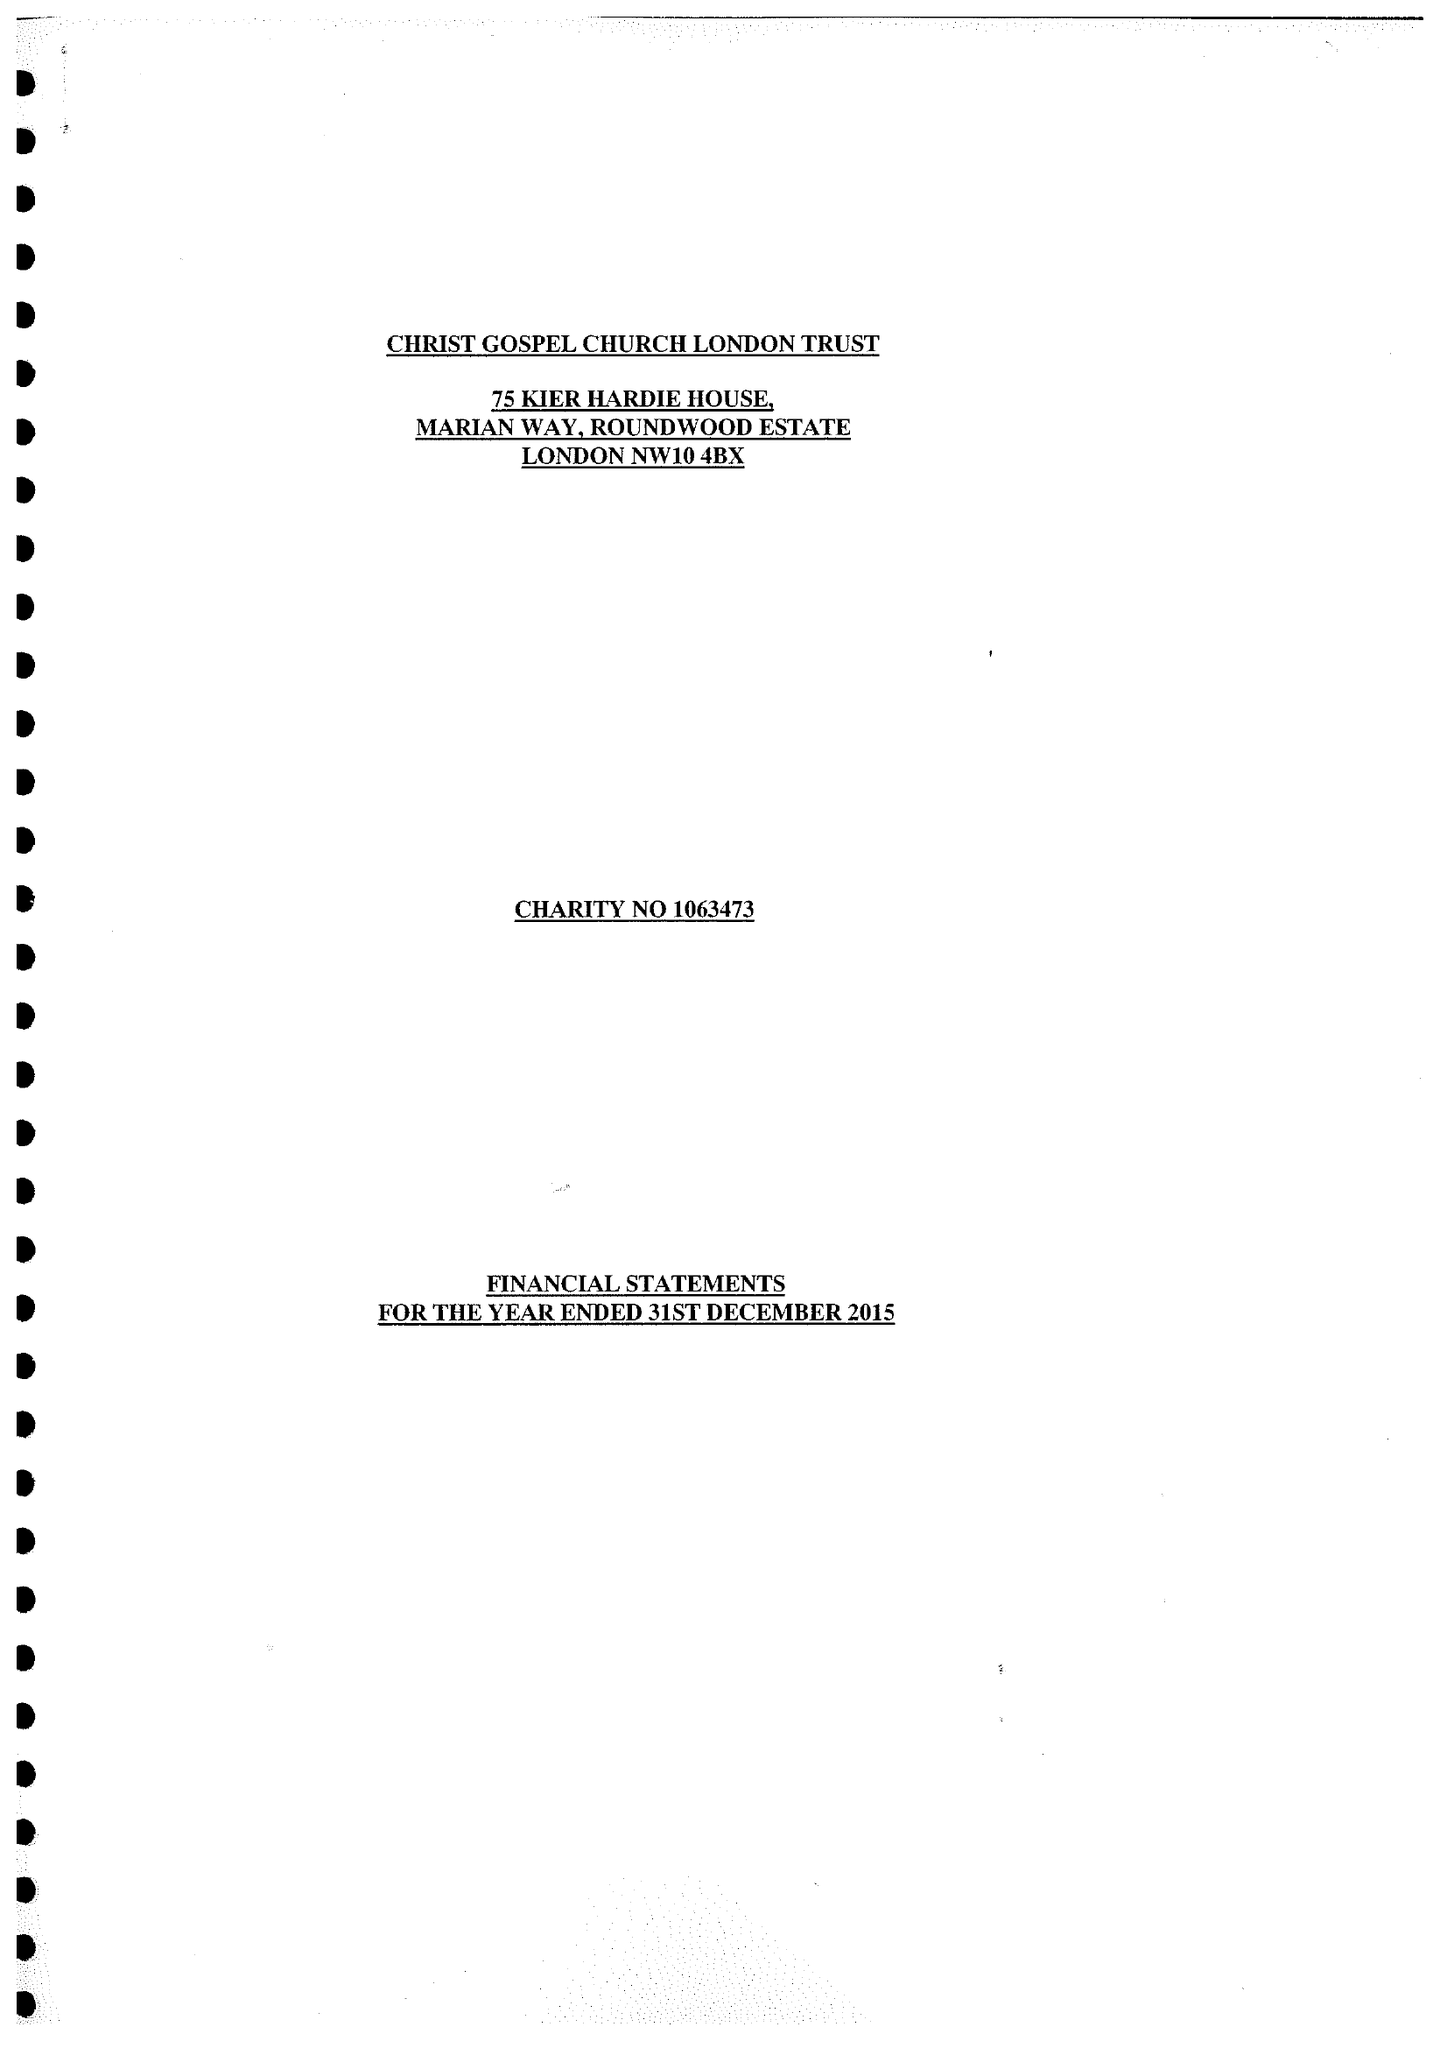What is the value for the report_date?
Answer the question using a single word or phrase. 2015-12-31 